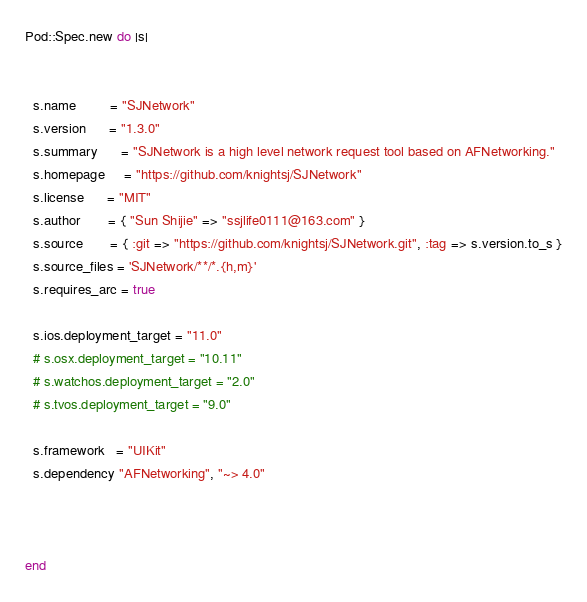<code> <loc_0><loc_0><loc_500><loc_500><_Ruby_>
Pod::Spec.new do |s|


  s.name         = "SJNetwork"
  s.version      = "1.3.0"
  s.summary      = "SJNetwork is a high level network request tool based on AFNetworking."
  s.homepage     = "https://github.com/knightsj/SJNetwork"
  s.license      = "MIT"
  s.author       = { "Sun Shijie" => "ssjlife0111@163.com" }
  s.source       = { :git => "https://github.com/knightsj/SJNetwork.git", :tag => s.version.to_s }
  s.source_files = 'SJNetwork/**/*.{h,m}'
  s.requires_arc = true

  s.ios.deployment_target = "11.0"
  # s.osx.deployment_target = "10.11"
  # s.watchos.deployment_target = "2.0"
  # s.tvos.deployment_target = "9.0"

  s.framework   = "UIKit"
  s.dependency "AFNetworking", "~> 4.0"



end
</code> 